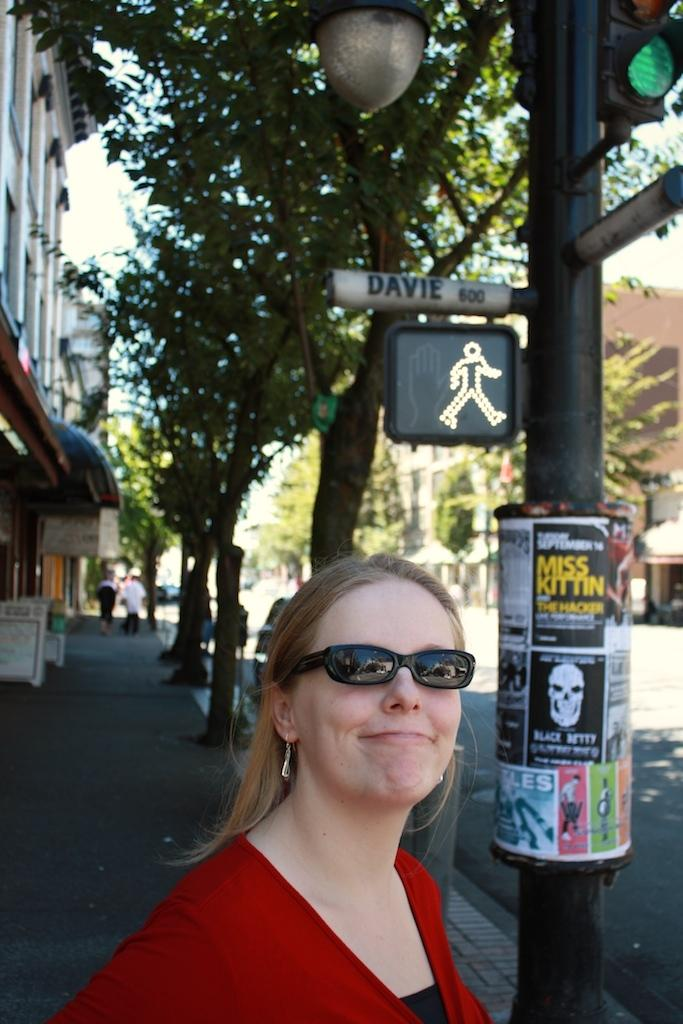Who is present in the image? There is a woman in the image. What is the woman wearing on her face? The woman is wearing spectacles. Where is the woman located in the image? The woman is standing by the side of the road. What can be seen in the distance in the image? There are trees and buildings visible in the background of the image. What type of powder is the woman holding in the image? There is no powder visible in the image; the woman is not holding anything. Can you see any rabbits in the image? There are no rabbits present in the image. 